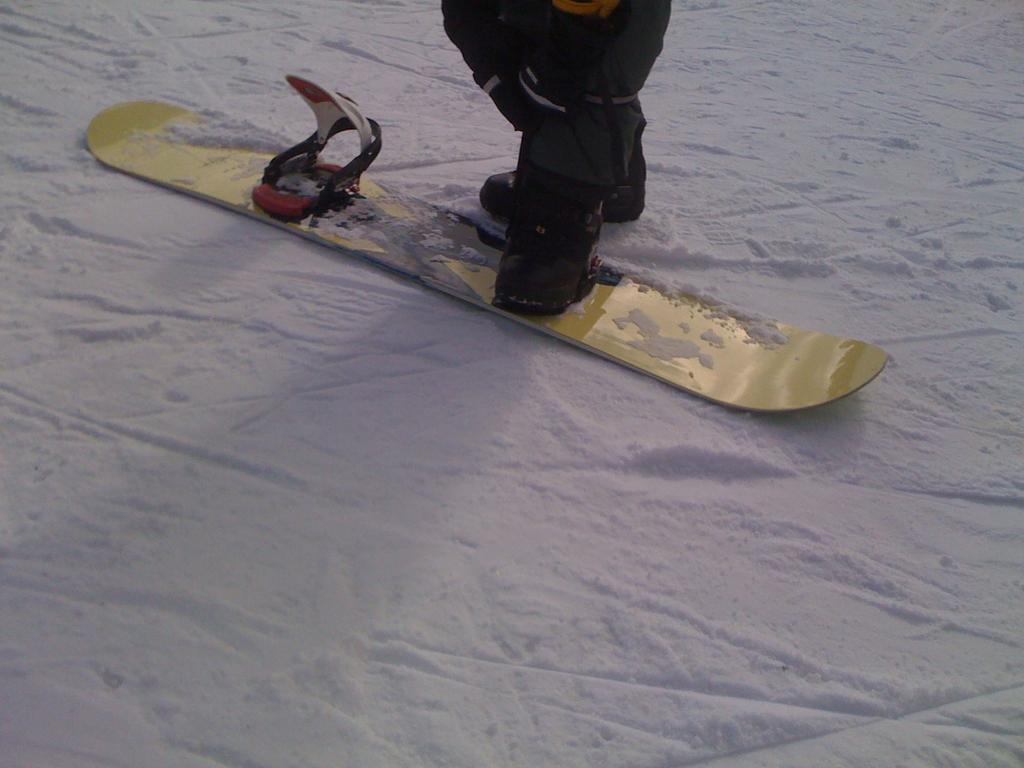Who or what is present in the image? There is a person in the image. What is the person wearing on their feet? The person is wearing shoes. What activity is the person attempting to do? The person is trying to put their legs on a yellow snowboard. What type of terrain is visible at the bottom of the image? There is snow visible at the bottom of the image. What type of arch can be seen in the image? There is no arch present in the image. Can you identify the judge in the image? There is no judge present in the image. 